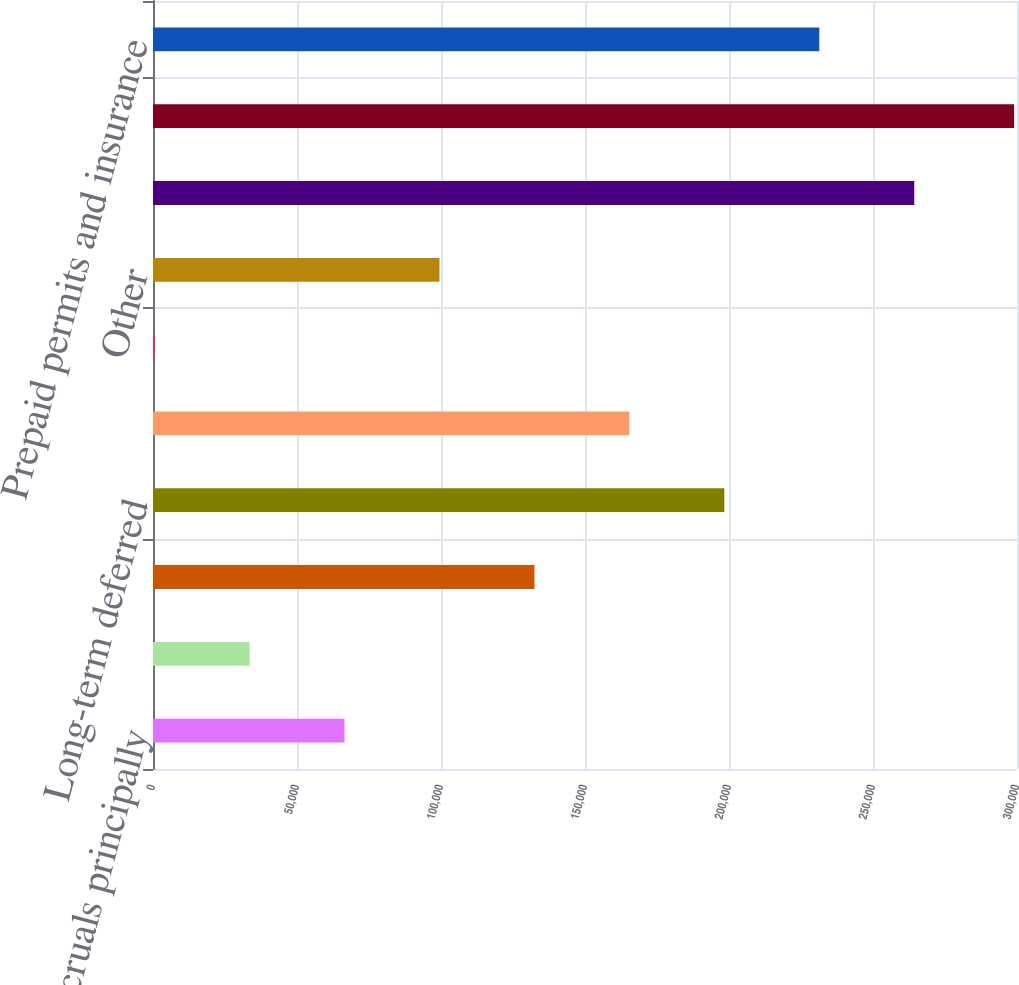Convert chart. <chart><loc_0><loc_0><loc_500><loc_500><bar_chart><fcel>Claims accruals principally<fcel>Accounts receivable<fcel>Vacation pay<fcel>Long-term deferred<fcel>State tax contingency and<fcel>Interest rate swap<fcel>Other<fcel>Total gross deferred tax<fcel>Plant and equipment<fcel>Prepaid permits and insurance<nl><fcel>66497<fcel>33525.5<fcel>132440<fcel>198383<fcel>165412<fcel>554<fcel>99468.5<fcel>264326<fcel>298991<fcel>231354<nl></chart> 